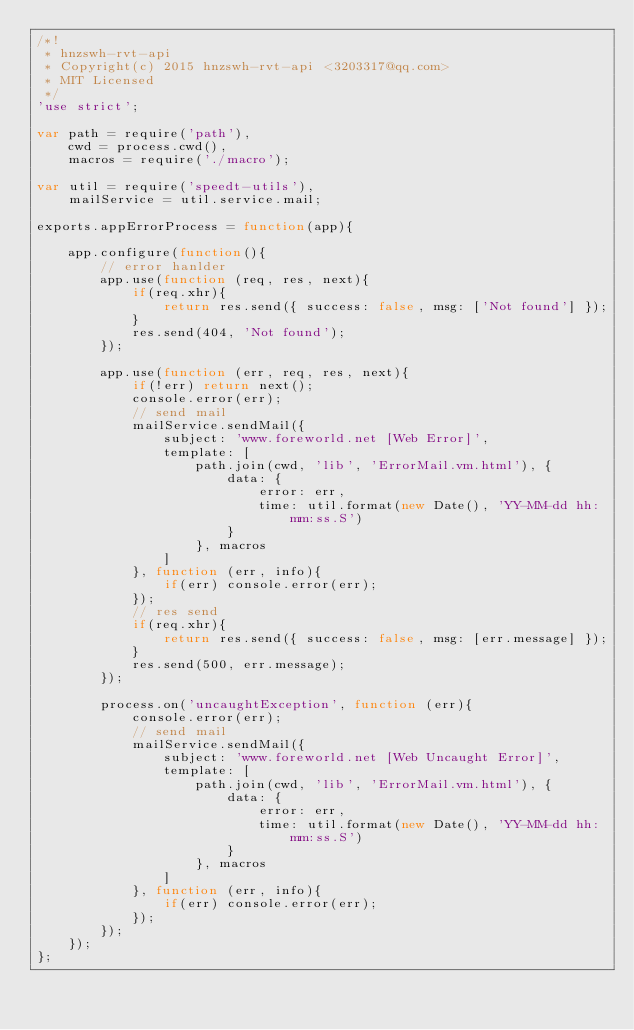<code> <loc_0><loc_0><loc_500><loc_500><_JavaScript_>/*!
 * hnzswh-rvt-api
 * Copyright(c) 2015 hnzswh-rvt-api <3203317@qq.com>
 * MIT Licensed
 */
'use strict';

var path = require('path'),
	cwd = process.cwd(),
	macros = require('./macro');

var util = require('speedt-utils'),
	mailService = util.service.mail;

exports.appErrorProcess = function(app){

	app.configure(function(){
		// error hanlder
		app.use(function (req, res, next){
			if(req.xhr){
				return res.send({ success: false, msg: ['Not found'] });
			}
			res.send(404, 'Not found');
		});

		app.use(function (err, req, res, next){
			if(!err) return next();
			console.error(err);
			// send mail
			mailService.sendMail({
				subject: 'www.foreworld.net [Web Error]',
				template: [
					path.join(cwd, 'lib', 'ErrorMail.vm.html'), {
						data: {
							error: err,
							time: util.format(new Date(), 'YY-MM-dd hh:mm:ss.S')
						}
					}, macros
				]
			}, function (err, info){
				if(err) console.error(err);
			});
			// res send
			if(req.xhr){
				return res.send({ success: false, msg: [err.message] });
			}
			res.send(500, err.message);
		});

		process.on('uncaughtException', function (err){
			console.error(err);
			// send mail
			mailService.sendMail({
				subject: 'www.foreworld.net [Web Uncaught Error]',
				template: [
					path.join(cwd, 'lib', 'ErrorMail.vm.html'), {
						data: {
							error: err,
							time: util.format(new Date(), 'YY-MM-dd hh:mm:ss.S')
						}
					}, macros
				]
			}, function (err, info){
				if(err) console.error(err);
			});
		});
	});
};</code> 